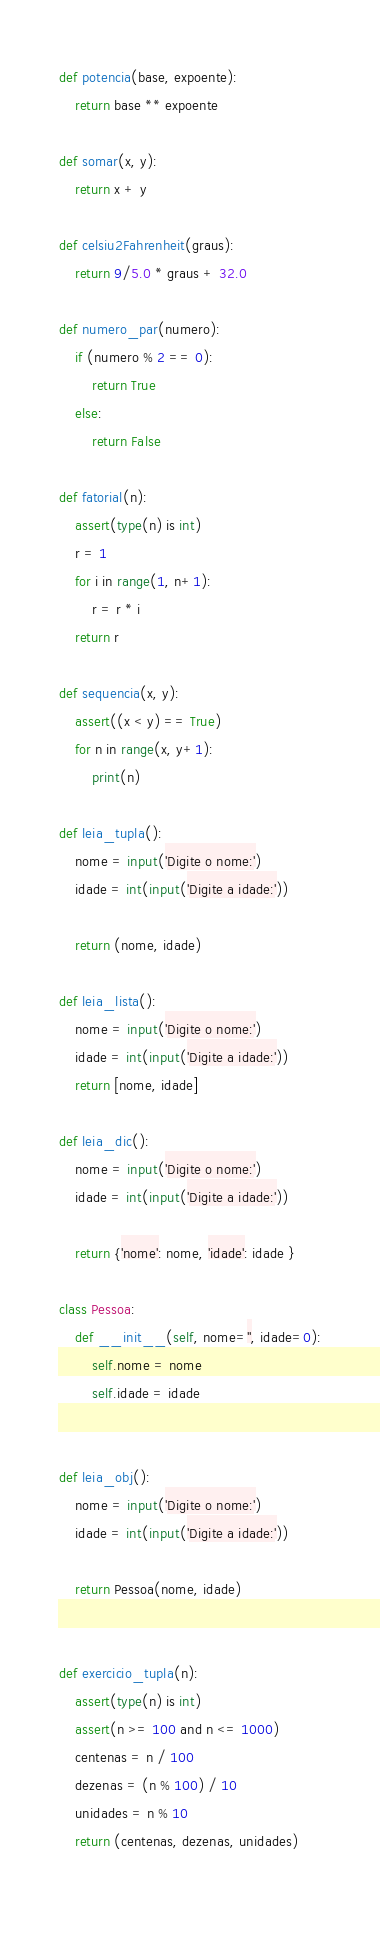<code> <loc_0><loc_0><loc_500><loc_500><_Python_>def potencia(base, expoente):
    return base ** expoente

def somar(x, y):
    return x + y

def celsiu2Fahrenheit(graus):
    return 9/5.0 * graus + 32.0

def numero_par(numero):
    if (numero % 2 == 0):
        return True
    else:
        return False

def fatorial(n):
    assert(type(n) is int)
    r = 1
    for i in range(1, n+1):
        r = r * i
    return r

def sequencia(x, y):
    assert((x < y) == True)
    for n in range(x, y+1):
        print(n)

def leia_tupla():
    nome = input('Digite o nome:')
    idade = int(input('Digite a idade:'))

    return (nome, idade)

def leia_lista():
    nome = input('Digite o nome:')
    idade = int(input('Digite a idade:'))
    return [nome, idade]

def leia_dic():
    nome = input('Digite o nome:')
    idade = int(input('Digite a idade:'))

    return {'nome': nome, 'idade': idade }

class Pessoa:
    def __init__(self, nome='', idade=0):
        self.nome = nome
        self.idade = idade


def leia_obj():
    nome = input('Digite o nome:')
    idade = int(input('Digite a idade:'))

    return Pessoa(nome, idade)
    

def exercicio_tupla(n):
    assert(type(n) is int)
    assert(n >= 100 and n <= 1000)
    centenas = n / 100
    dezenas = (n % 100) / 10
    unidades = n % 10
    return (centenas, dezenas, unidades)
    


</code> 